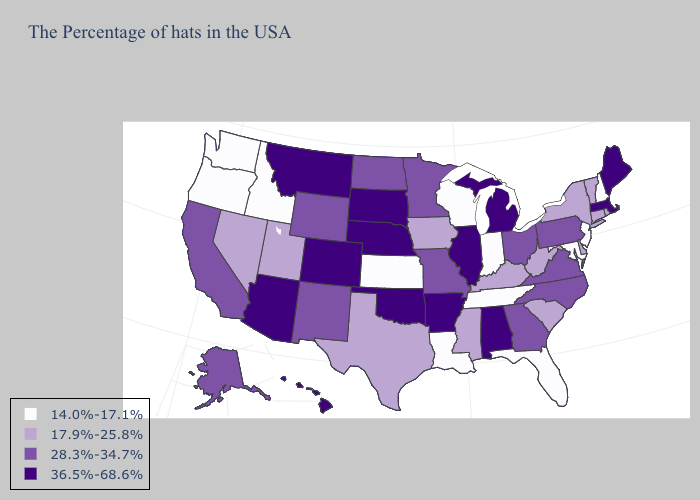Name the states that have a value in the range 17.9%-25.8%?
Give a very brief answer. Rhode Island, Vermont, Connecticut, New York, Delaware, South Carolina, West Virginia, Kentucky, Mississippi, Iowa, Texas, Utah, Nevada. What is the highest value in the Northeast ?
Keep it brief. 36.5%-68.6%. Does the map have missing data?
Give a very brief answer. No. Which states have the lowest value in the USA?
Give a very brief answer. New Hampshire, New Jersey, Maryland, Florida, Indiana, Tennessee, Wisconsin, Louisiana, Kansas, Idaho, Washington, Oregon. Does Georgia have the highest value in the USA?
Be succinct. No. Name the states that have a value in the range 17.9%-25.8%?
Write a very short answer. Rhode Island, Vermont, Connecticut, New York, Delaware, South Carolina, West Virginia, Kentucky, Mississippi, Iowa, Texas, Utah, Nevada. Which states have the lowest value in the USA?
Keep it brief. New Hampshire, New Jersey, Maryland, Florida, Indiana, Tennessee, Wisconsin, Louisiana, Kansas, Idaho, Washington, Oregon. Does the first symbol in the legend represent the smallest category?
Answer briefly. Yes. What is the value of Michigan?
Write a very short answer. 36.5%-68.6%. What is the highest value in the USA?
Answer briefly. 36.5%-68.6%. Does Illinois have the lowest value in the MidWest?
Keep it brief. No. Which states have the lowest value in the USA?
Be succinct. New Hampshire, New Jersey, Maryland, Florida, Indiana, Tennessee, Wisconsin, Louisiana, Kansas, Idaho, Washington, Oregon. Does Alabama have the same value as Oregon?
Be succinct. No. Name the states that have a value in the range 17.9%-25.8%?
Keep it brief. Rhode Island, Vermont, Connecticut, New York, Delaware, South Carolina, West Virginia, Kentucky, Mississippi, Iowa, Texas, Utah, Nevada. 